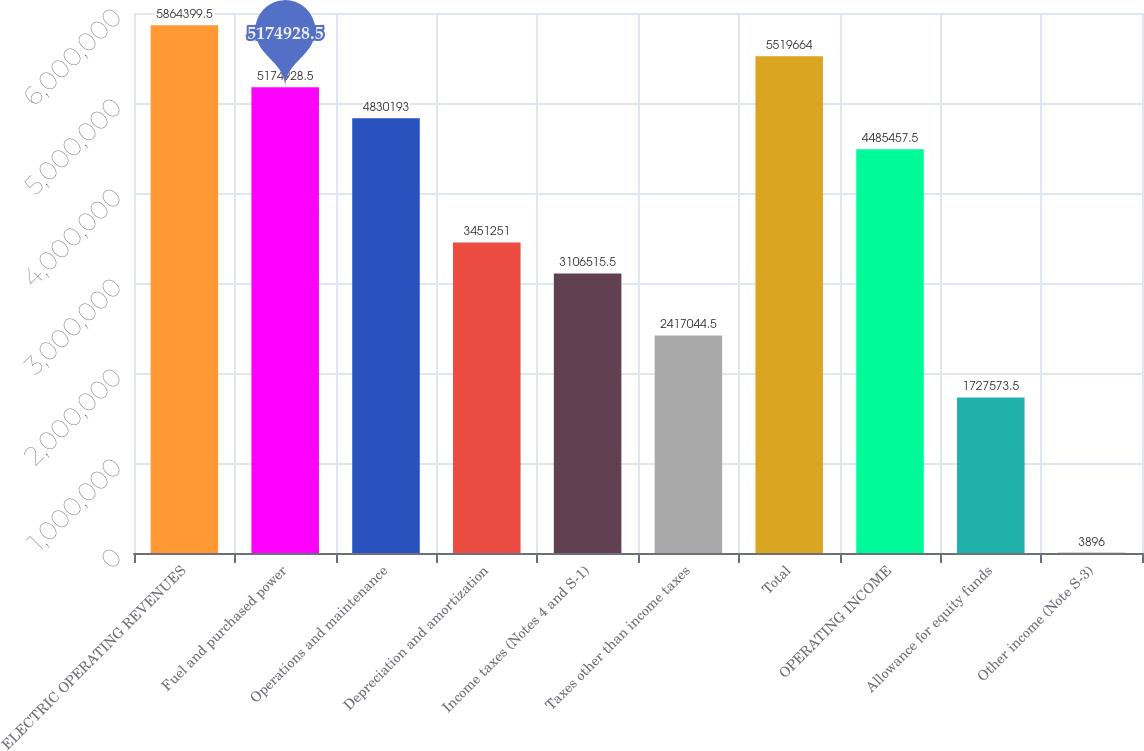<chart> <loc_0><loc_0><loc_500><loc_500><bar_chart><fcel>ELECTRIC OPERATING REVENUES<fcel>Fuel and purchased power<fcel>Operations and maintenance<fcel>Depreciation and amortization<fcel>Income taxes (Notes 4 and S-1)<fcel>Taxes other than income taxes<fcel>Total<fcel>OPERATING INCOME<fcel>Allowance for equity funds<fcel>Other income (Note S-3)<nl><fcel>5.8644e+06<fcel>5.17493e+06<fcel>4.83019e+06<fcel>3.45125e+06<fcel>3.10652e+06<fcel>2.41704e+06<fcel>5.51966e+06<fcel>4.48546e+06<fcel>1.72757e+06<fcel>3896<nl></chart> 